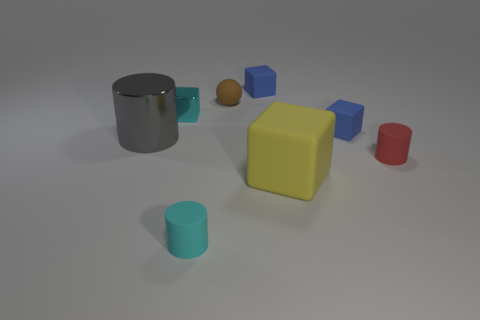Subtract all small metallic blocks. How many blocks are left? 3 Subtract all yellow blocks. How many blocks are left? 3 Subtract all purple blocks. Subtract all red cylinders. How many blocks are left? 4 Add 1 big rubber things. How many objects exist? 9 Subtract all balls. How many objects are left? 7 Add 4 small matte balls. How many small matte balls exist? 5 Subtract 0 purple cubes. How many objects are left? 8 Subtract all red matte objects. Subtract all big shiny cubes. How many objects are left? 7 Add 6 matte balls. How many matte balls are left? 7 